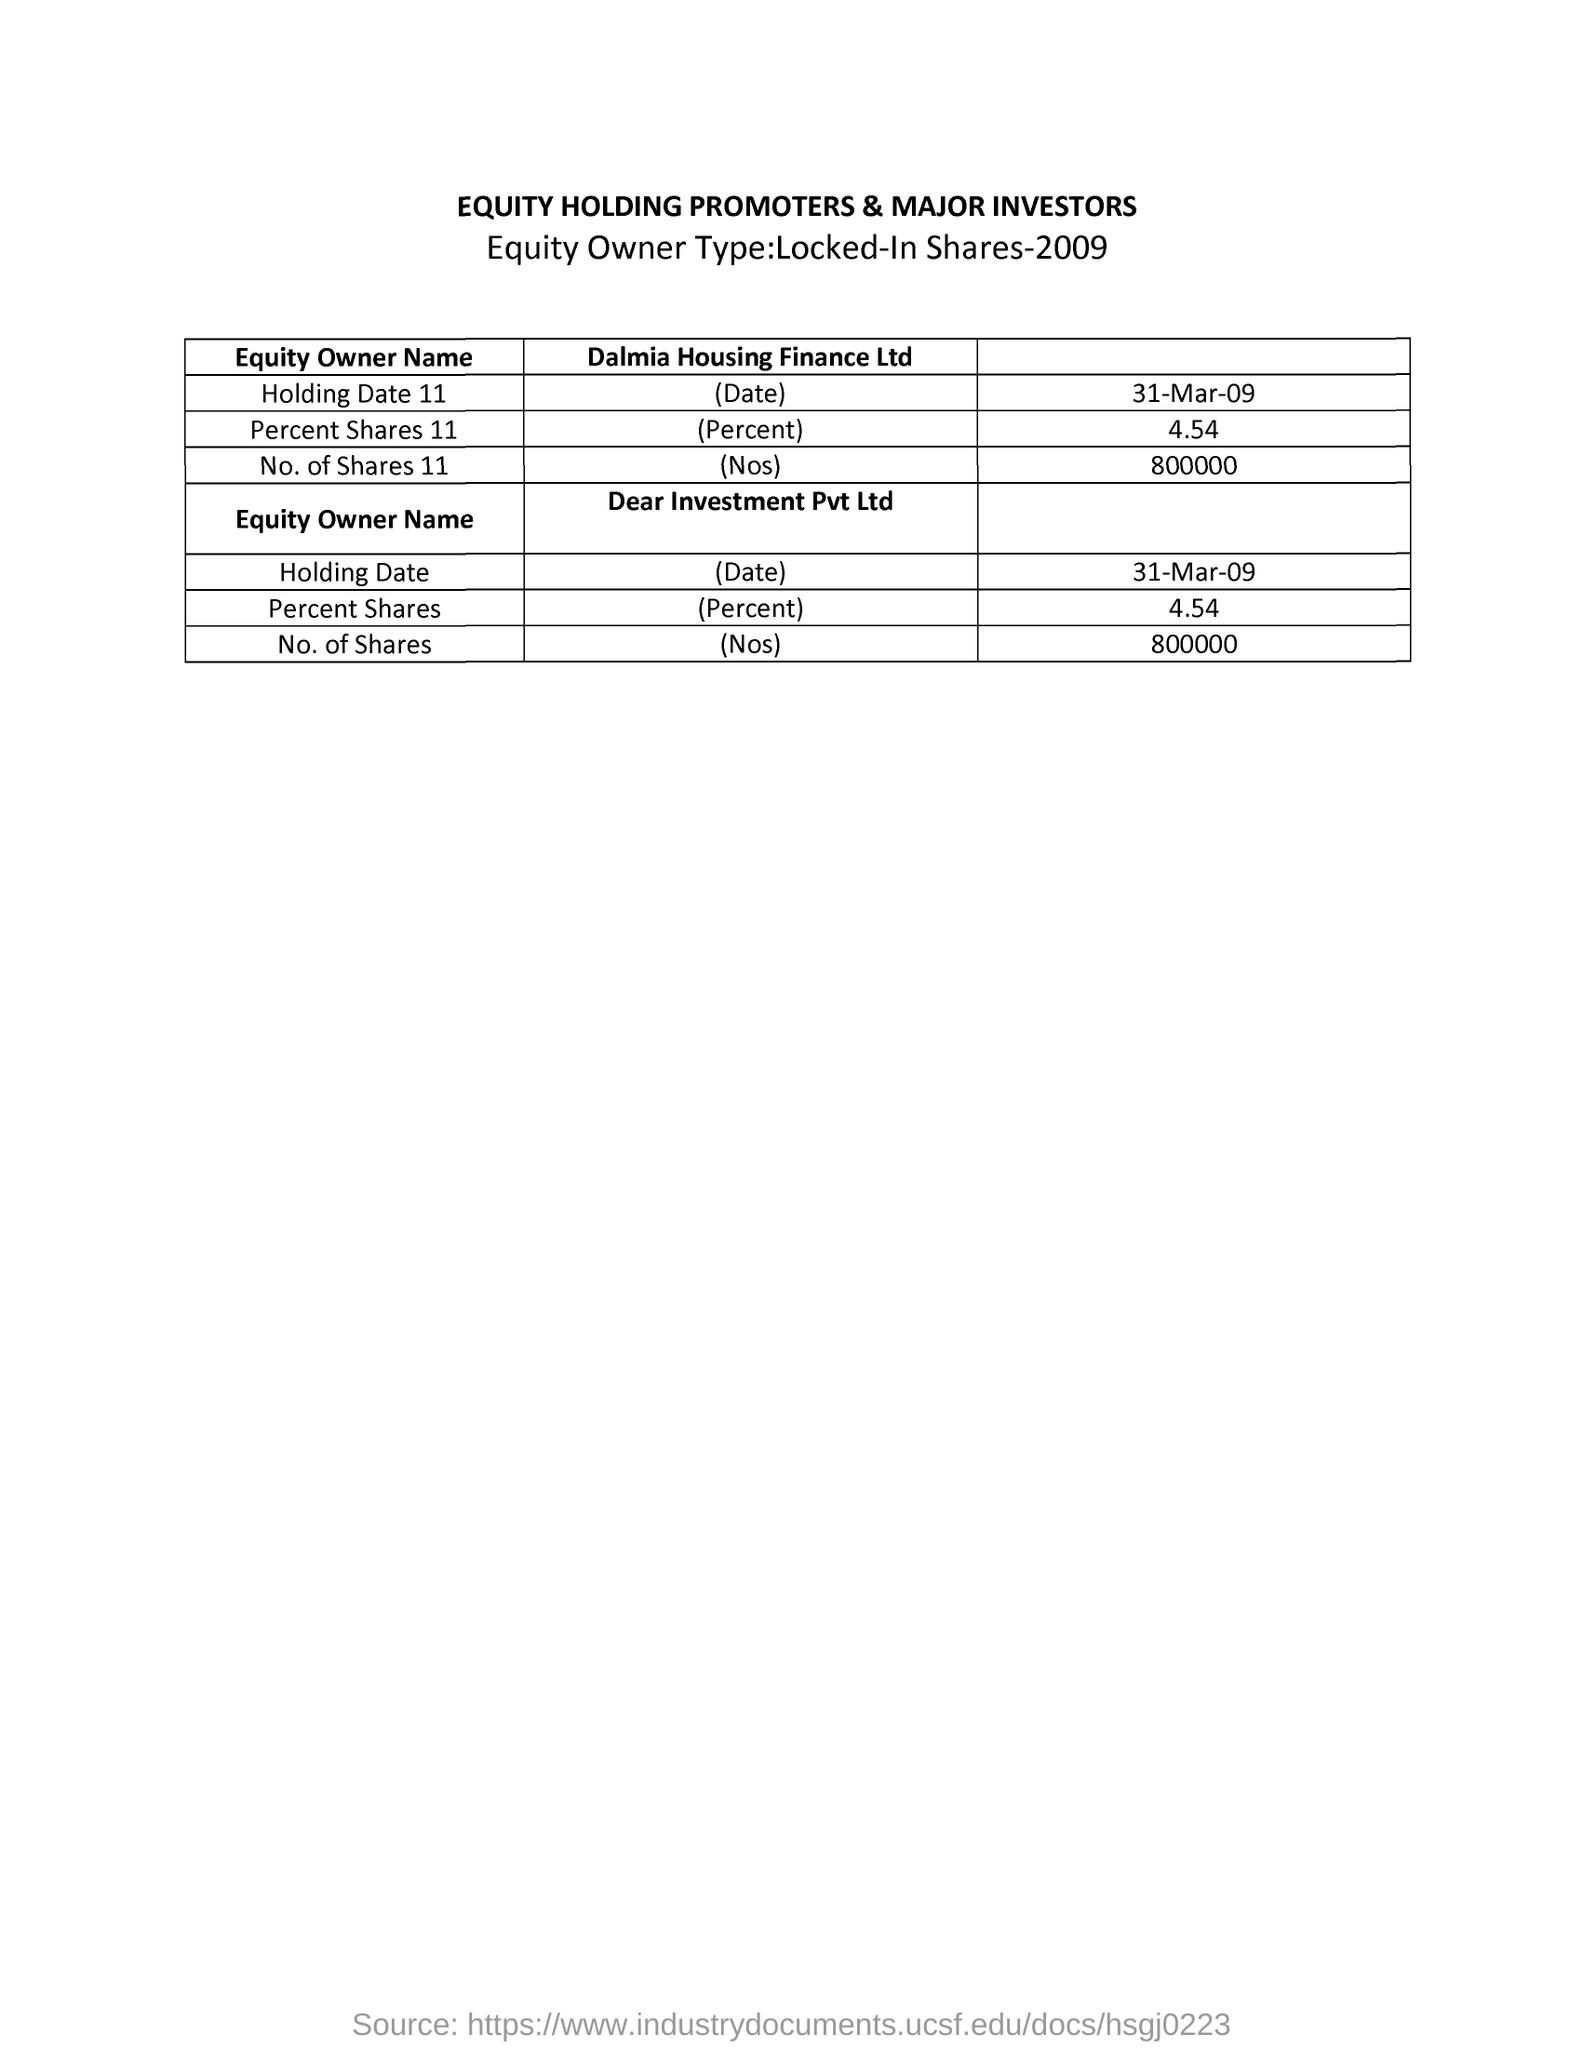List a handful of essential elements in this visual. Dear Investment Pvt. Ltd. has 800,000 shares. As of March 31, 2009, the holding date for Dalmia Housing Finance Ltd. is March 31, 2009. The table provides information about the equity holding of promoters and major investors of a company. As of March 31, 2009, the holding date for Dear Investment Pvt. Ltd. was "31-Mar-09. 45.4% is the percent share of Dear Investment Pvt. Ltd. 